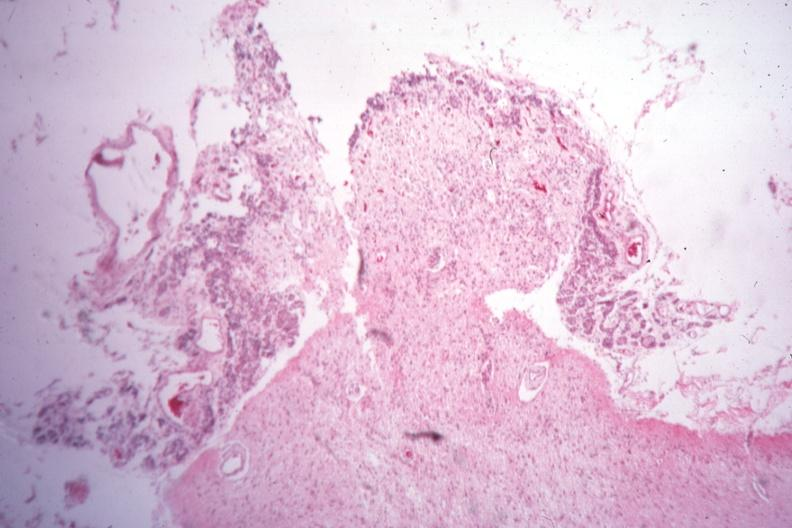s endocrine present?
Answer the question using a single word or phrase. Yes 